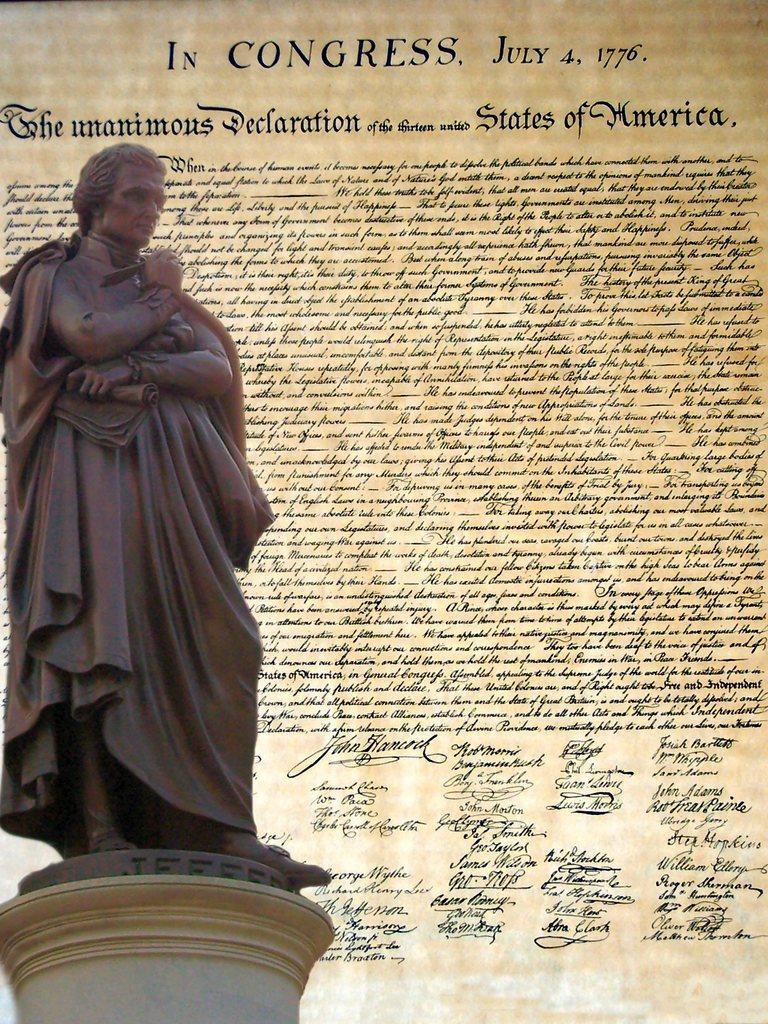Please provide a concise description of this image. In this image we can see a statue. In the background we can see text written on a poster. 